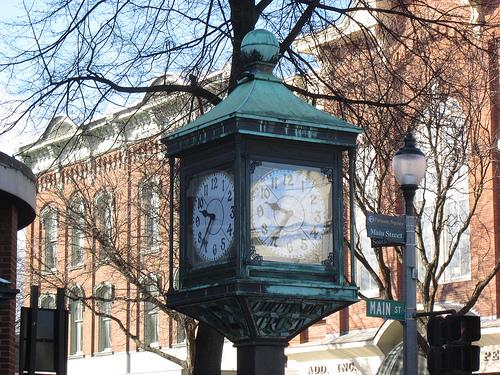Describe the ambiance of the sky in the image. The sky is blue and mildly cloudy, giving the scene a calm and somewhat nostalgic atmosphere. Describe the location and details of the green street sign. The green rectangular street sign with white writing reads "Main St" and is attached to the light pole on the right side of the clock. Provide a succinct description of the central object in the image. A large, vintage clock with two visible faces and black hands is showing 9:35 in front of a large building. Mention a few key elements in the scene and the general atmosphere. An old-looking clock is in front of a big brick building, with a leafless tree, blue sky, and a Main Street sign nearby. Mention the crosswalk device's location in relation to the clock. The black crosswalk signal with a red light is positioned to the bottom right of the vintage clock. Provide a brief description of the street light element in the image. A decorative gas street lamp with a black top is attached to a light pole to the right of the vintage clock. Give a detailed account of the clock's appearance. The large, arched clock has a white face, dark numbers, and black hands, all behind glass and displaying a time of 9:35. What type of building is situated in the background of the image? A two-story brick building with eight windows is in the background behind the old-looking clock. Identify the main objects on the left bottom corner of the image. The back of a large sign and three windows on a brick building are located in the bottom left corner of the image. List some notable features surrounding the clock in the image. A tree with bare branches, a green Main Street sign, a pedestrian light, and a grey lamp post are surrounding the clock. There's a small digital clock next to the large clock, right? The original captions mention a large clock but don't mention a small digital clock. This instruction adds a non-existing object with different attributes. Is there a yellow street sign that reads "Main St" in the picture? The original caption mentions a green street sign that reads main st, but not a yellow one. This instruction changes the color attribute of the street sign. Find the pink arched window with multiple panes on the right side of the image. The original caption mentions a large arched window with multiple panes, but it does not say it's pink. This instruction changes the color attribute of the window. Do you notice any neon signs at the top of the light pole? The original caption mentions two signs at the top of a light pole but doesn't mention them being neon. This instruction adds a non-existing attribute (neon) to the signs. Notice how the white hands on the right side of the clock face are pointing to 12:00. The original caption mentions black hands on the clock face. This instruction changes the color attribute of the hands and the time the clock is showing. The large brick building across the street is a one-story structure, correct? The original caption mentions a two-story brick building. This instruction changes the attribute of the number of stories in the building from two to one. Can you see a red traffic light attached to the pole above the pedestrian signal? The original caption mentions a black crosswalk signal, but not a red traffic light. This instruction adds a non-existing traffic light with a new color attribute. Find a clock with a bright orange face and dark numbers in the image. The original captions mention a clock with a white face and dark numbers. This instruction changes the color attribute of the clock face to orange. Are the clouds in the sky pink and fluffy? The original caption mentions the sky is blue with a few clouds. This instruction changes the color attribute of the clouds to pink. The tree behind the clocks has plenty of leaves, doesn't it? The original caption mentions a tree behind the clocks with no leaves. This instruction contradicts the original caption by suggesting the tree has many leaves. 